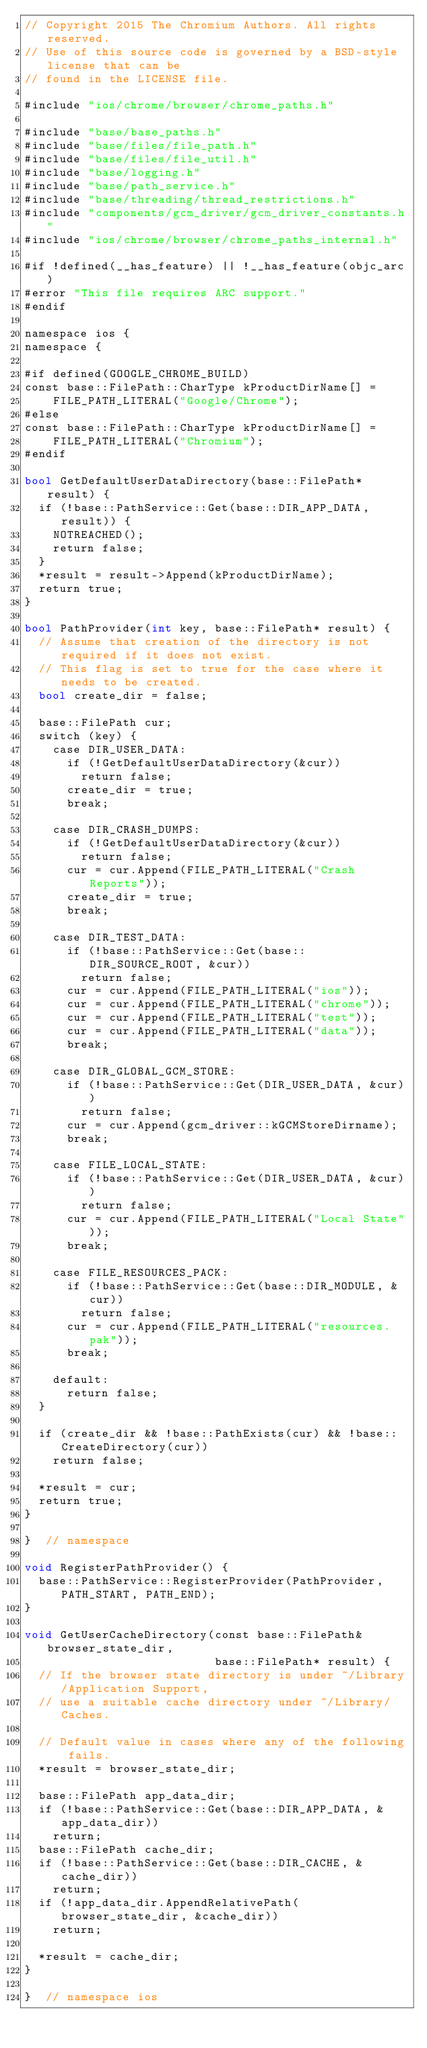Convert code to text. <code><loc_0><loc_0><loc_500><loc_500><_ObjectiveC_>// Copyright 2015 The Chromium Authors. All rights reserved.
// Use of this source code is governed by a BSD-style license that can be
// found in the LICENSE file.

#include "ios/chrome/browser/chrome_paths.h"

#include "base/base_paths.h"
#include "base/files/file_path.h"
#include "base/files/file_util.h"
#include "base/logging.h"
#include "base/path_service.h"
#include "base/threading/thread_restrictions.h"
#include "components/gcm_driver/gcm_driver_constants.h"
#include "ios/chrome/browser/chrome_paths_internal.h"

#if !defined(__has_feature) || !__has_feature(objc_arc)
#error "This file requires ARC support."
#endif

namespace ios {
namespace {

#if defined(GOOGLE_CHROME_BUILD)
const base::FilePath::CharType kProductDirName[] =
    FILE_PATH_LITERAL("Google/Chrome");
#else
const base::FilePath::CharType kProductDirName[] =
    FILE_PATH_LITERAL("Chromium");
#endif

bool GetDefaultUserDataDirectory(base::FilePath* result) {
  if (!base::PathService::Get(base::DIR_APP_DATA, result)) {
    NOTREACHED();
    return false;
  }
  *result = result->Append(kProductDirName);
  return true;
}

bool PathProvider(int key, base::FilePath* result) {
  // Assume that creation of the directory is not required if it does not exist.
  // This flag is set to true for the case where it needs to be created.
  bool create_dir = false;

  base::FilePath cur;
  switch (key) {
    case DIR_USER_DATA:
      if (!GetDefaultUserDataDirectory(&cur))
        return false;
      create_dir = true;
      break;

    case DIR_CRASH_DUMPS:
      if (!GetDefaultUserDataDirectory(&cur))
        return false;
      cur = cur.Append(FILE_PATH_LITERAL("Crash Reports"));
      create_dir = true;
      break;

    case DIR_TEST_DATA:
      if (!base::PathService::Get(base::DIR_SOURCE_ROOT, &cur))
        return false;
      cur = cur.Append(FILE_PATH_LITERAL("ios"));
      cur = cur.Append(FILE_PATH_LITERAL("chrome"));
      cur = cur.Append(FILE_PATH_LITERAL("test"));
      cur = cur.Append(FILE_PATH_LITERAL("data"));
      break;

    case DIR_GLOBAL_GCM_STORE:
      if (!base::PathService::Get(DIR_USER_DATA, &cur))
        return false;
      cur = cur.Append(gcm_driver::kGCMStoreDirname);
      break;

    case FILE_LOCAL_STATE:
      if (!base::PathService::Get(DIR_USER_DATA, &cur))
        return false;
      cur = cur.Append(FILE_PATH_LITERAL("Local State"));
      break;

    case FILE_RESOURCES_PACK:
      if (!base::PathService::Get(base::DIR_MODULE, &cur))
        return false;
      cur = cur.Append(FILE_PATH_LITERAL("resources.pak"));
      break;

    default:
      return false;
  }

  if (create_dir && !base::PathExists(cur) && !base::CreateDirectory(cur))
    return false;

  *result = cur;
  return true;
}

}  // namespace

void RegisterPathProvider() {
  base::PathService::RegisterProvider(PathProvider, PATH_START, PATH_END);
}

void GetUserCacheDirectory(const base::FilePath& browser_state_dir,
                           base::FilePath* result) {
  // If the browser state directory is under ~/Library/Application Support,
  // use a suitable cache directory under ~/Library/Caches.

  // Default value in cases where any of the following fails.
  *result = browser_state_dir;

  base::FilePath app_data_dir;
  if (!base::PathService::Get(base::DIR_APP_DATA, &app_data_dir))
    return;
  base::FilePath cache_dir;
  if (!base::PathService::Get(base::DIR_CACHE, &cache_dir))
    return;
  if (!app_data_dir.AppendRelativePath(browser_state_dir, &cache_dir))
    return;

  *result = cache_dir;
}

}  // namespace ios
</code> 